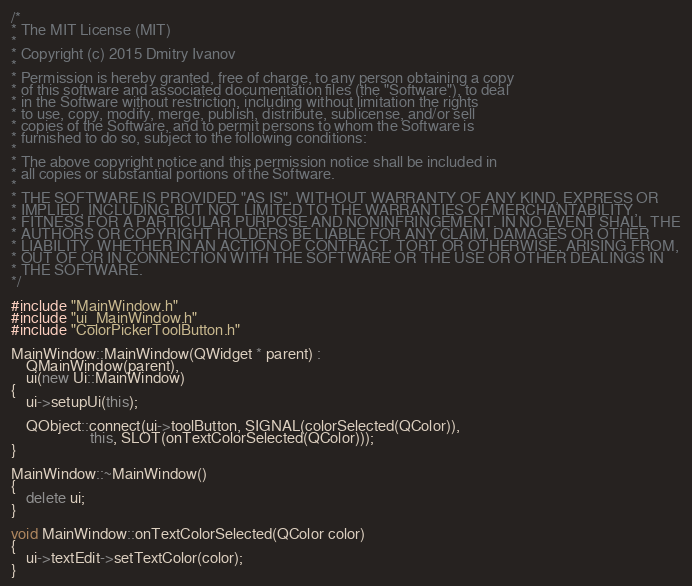<code> <loc_0><loc_0><loc_500><loc_500><_C++_>/*
* The MIT License (MIT)
*
* Copyright (c) 2015 Dmitry Ivanov
*
* Permission is hereby granted, free of charge, to any person obtaining a copy
* of this software and associated documentation files (the "Software"), to deal
* in the Software without restriction, including without limitation the rights
* to use, copy, modify, merge, publish, distribute, sublicense, and/or sell
* copies of the Software, and to permit persons to whom the Software is
* furnished to do so, subject to the following conditions:
*
* The above copyright notice and this permission notice shall be included in
* all copies or substantial portions of the Software.
*
* THE SOFTWARE IS PROVIDED "AS IS", WITHOUT WARRANTY OF ANY KIND, EXPRESS OR
* IMPLIED, INCLUDING BUT NOT LIMITED TO THE WARRANTIES OF MERCHANTABILITY,
* FITNESS FOR A PARTICULAR PURPOSE AND NONINFRINGEMENT. IN NO EVENT SHALL THE
* AUTHORS OR COPYRIGHT HOLDERS BE LIABLE FOR ANY CLAIM, DAMAGES OR OTHER
* LIABILITY, WHETHER IN AN ACTION OF CONTRACT, TORT OR OTHERWISE, ARISING FROM,
* OUT OF OR IN CONNECTION WITH THE SOFTWARE OR THE USE OR OTHER DEALINGS IN
* THE SOFTWARE.
*/

#include "MainWindow.h"
#include "ui_MainWindow.h"
#include "ColorPickerToolButton.h"

MainWindow::MainWindow(QWidget * parent) :
    QMainWindow(parent),
    ui(new Ui::MainWindow)
{
    ui->setupUi(this);

    QObject::connect(ui->toolButton, SIGNAL(colorSelected(QColor)),
                     this, SLOT(onTextColorSelected(QColor)));
}

MainWindow::~MainWindow()
{
    delete ui;
}

void MainWindow::onTextColorSelected(QColor color)
{
    ui->textEdit->setTextColor(color);
}
</code> 